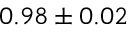<formula> <loc_0><loc_0><loc_500><loc_500>0 . 9 8 \pm 0 . 0 2</formula> 